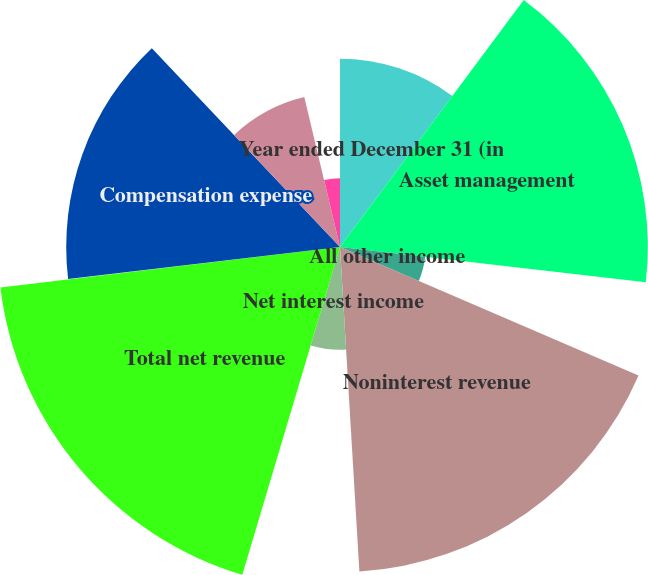Convert chart. <chart><loc_0><loc_0><loc_500><loc_500><pie_chart><fcel>Year ended December 31 (in<fcel>Asset management<fcel>All other income<fcel>Noninterest revenue<fcel>Net interest income<fcel>Total net revenue<fcel>Provision for credit losses<fcel>Compensation expense<fcel>Noncompensation expense<fcel>Amortization of intangibles<nl><fcel>10.18%<fcel>16.65%<fcel>4.64%<fcel>17.58%<fcel>5.56%<fcel>18.5%<fcel>0.02%<fcel>14.81%<fcel>8.34%<fcel>3.72%<nl></chart> 